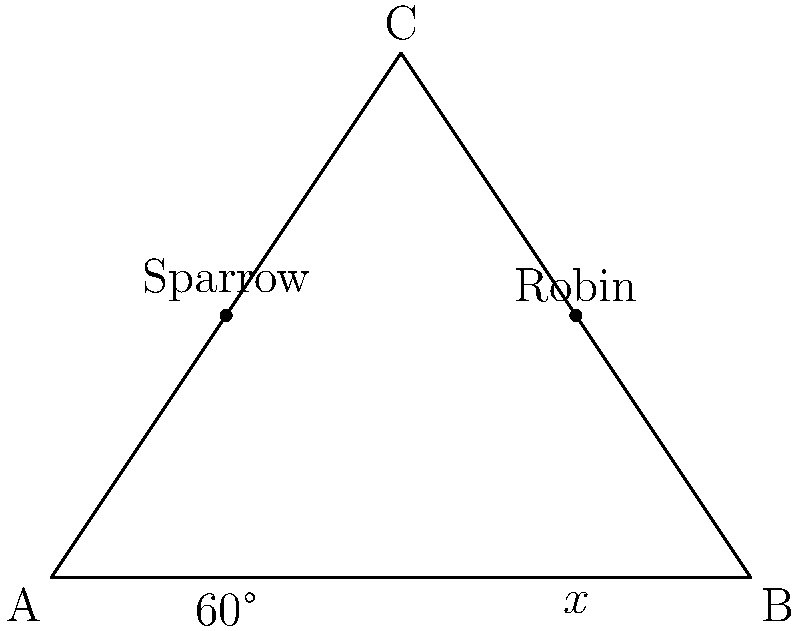In a tree, two branches form a 60° angle with the trunk. A sparrow nests on one branch, while a robin nests on the other. If the angle between the two branches is $x°$, what is the value of $x$? Let's approach this step-by-step:

1) In a triangle, the sum of all interior angles is always 180°.

2) We can see that the two branches and the trunk form a triangle.

3) We know one angle of this triangle: it's 60° (given in the question).

4) The angle we're looking for, $x°$, is the angle at the top of the triangle.

5) Let's call the third angle of the triangle $y°$.

6) Now we can set up an equation based on the fact that the sum of angles in a triangle is 180°:

   $60° + x° + y° = 180°$

7) We also know that the two branches form a straight line at the top of the triangle. A straight line is 180°.

8) This means that $x° + y° = 180°$

9) Substituting this into our first equation:

   $60° + (180°) = 180°$

10) Simplifying:

    $240° = 180°$

11) Subtracting 180° from both sides:

    $60° = x°$

Therefore, the angle between the two branches where the sparrow and robin nest is 60°.
Answer: 60° 